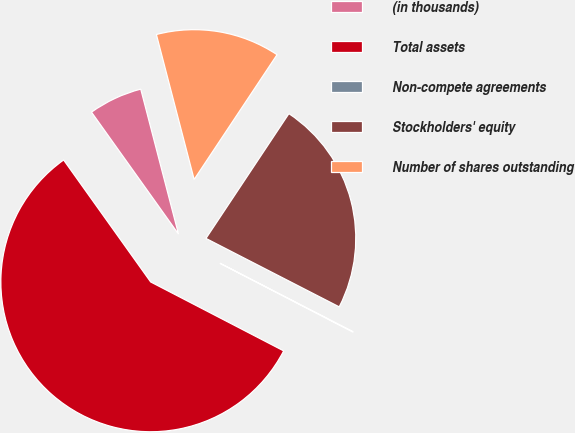Convert chart. <chart><loc_0><loc_0><loc_500><loc_500><pie_chart><fcel>(in thousands)<fcel>Total assets<fcel>Non-compete agreements<fcel>Stockholders' equity<fcel>Number of shares outstanding<nl><fcel>5.81%<fcel>57.53%<fcel>0.06%<fcel>23.22%<fcel>13.39%<nl></chart> 